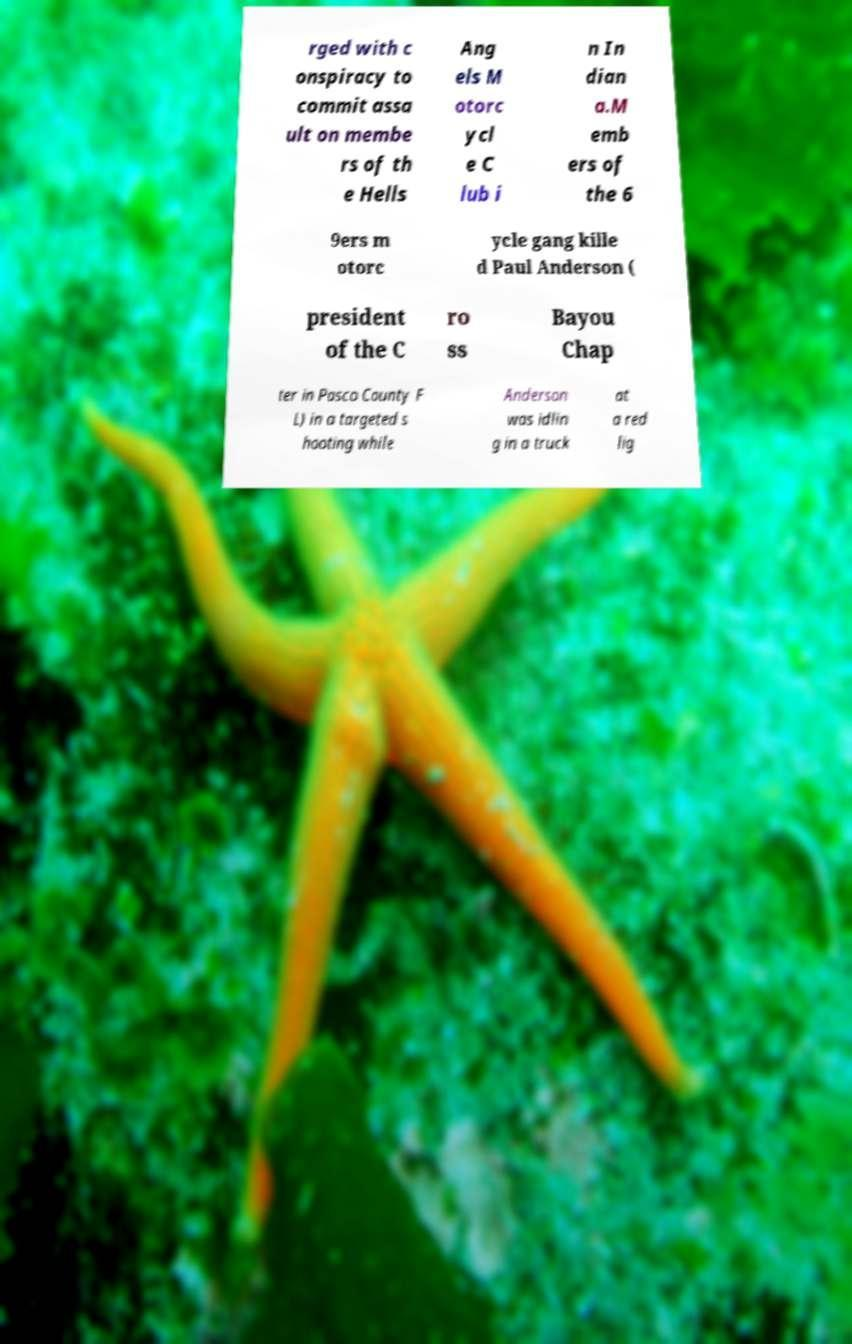What messages or text are displayed in this image? I need them in a readable, typed format. rged with c onspiracy to commit assa ult on membe rs of th e Hells Ang els M otorc ycl e C lub i n In dian a.M emb ers of the 6 9ers m otorc ycle gang kille d Paul Anderson ( president of the C ro ss Bayou Chap ter in Pasco County F L) in a targeted s hooting while Anderson was idlin g in a truck at a red lig 